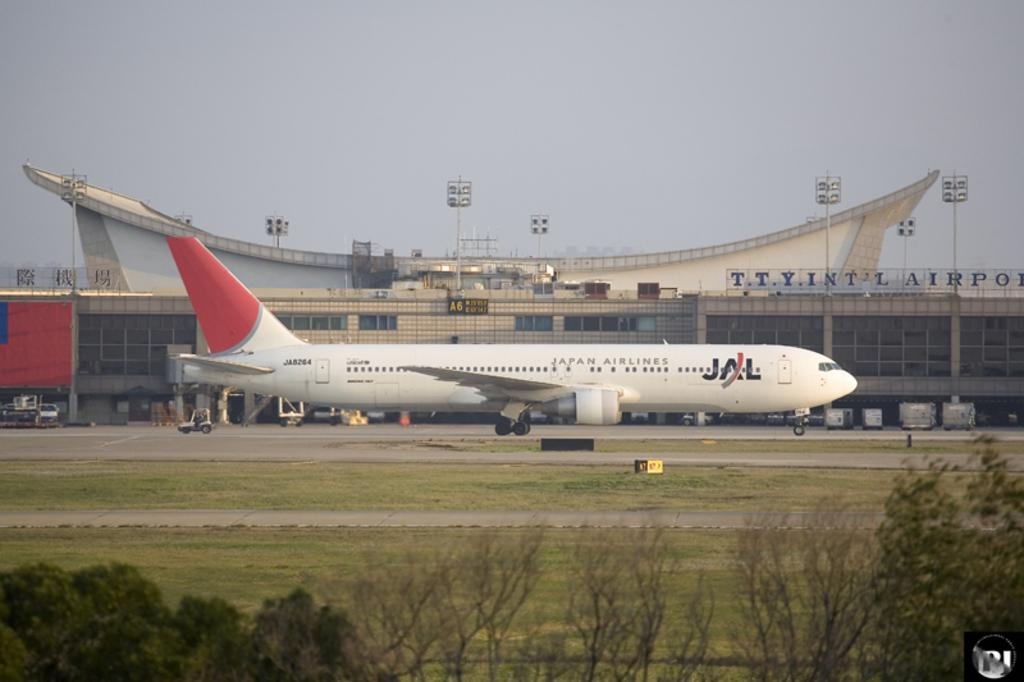Provide a one-sentence caption for the provided image. an airplane grounded, with a JAL decal on the side. 